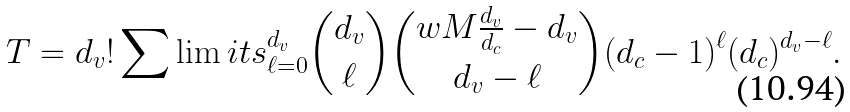Convert formula to latex. <formula><loc_0><loc_0><loc_500><loc_500>T = d _ { v } ! \sum \lim i t s _ { \ell = 0 } ^ { d _ { v } } \binom { d _ { v } } { \ell } \binom { w M \frac { d _ { v } } { d _ { c } } - d _ { v } } { d _ { v } - \ell } ( d _ { c } - 1 ) ^ { \ell } ( d _ { c } ) ^ { d _ { v } - \ell } .</formula> 